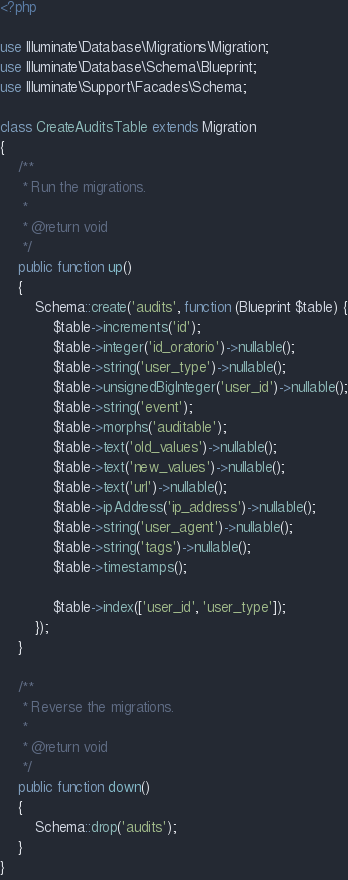Convert code to text. <code><loc_0><loc_0><loc_500><loc_500><_PHP_><?php

use Illuminate\Database\Migrations\Migration;
use Illuminate\Database\Schema\Blueprint;
use Illuminate\Support\Facades\Schema;

class CreateAuditsTable extends Migration
{
    /**
     * Run the migrations.
     *
     * @return void
     */
    public function up()
    {
        Schema::create('audits', function (Blueprint $table) {
            $table->increments('id');
            $table->integer('id_oratorio')->nullable();
            $table->string('user_type')->nullable();
            $table->unsignedBigInteger('user_id')->nullable();
            $table->string('event');
            $table->morphs('auditable');
            $table->text('old_values')->nullable();
            $table->text('new_values')->nullable();
            $table->text('url')->nullable();
            $table->ipAddress('ip_address')->nullable();
            $table->string('user_agent')->nullable();
            $table->string('tags')->nullable();
            $table->timestamps();

            $table->index(['user_id', 'user_type']);
        });
    }

    /**
     * Reverse the migrations.
     *
     * @return void
     */
    public function down()
    {
        Schema::drop('audits');
    }
}
</code> 